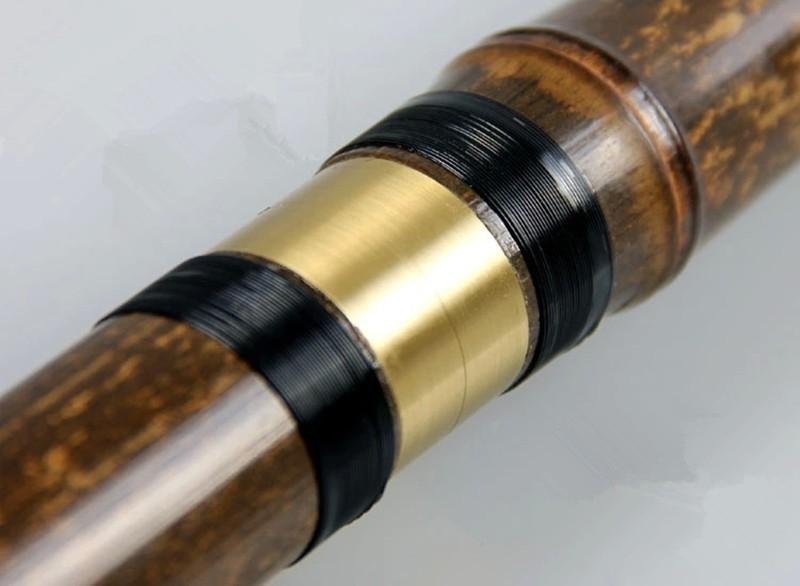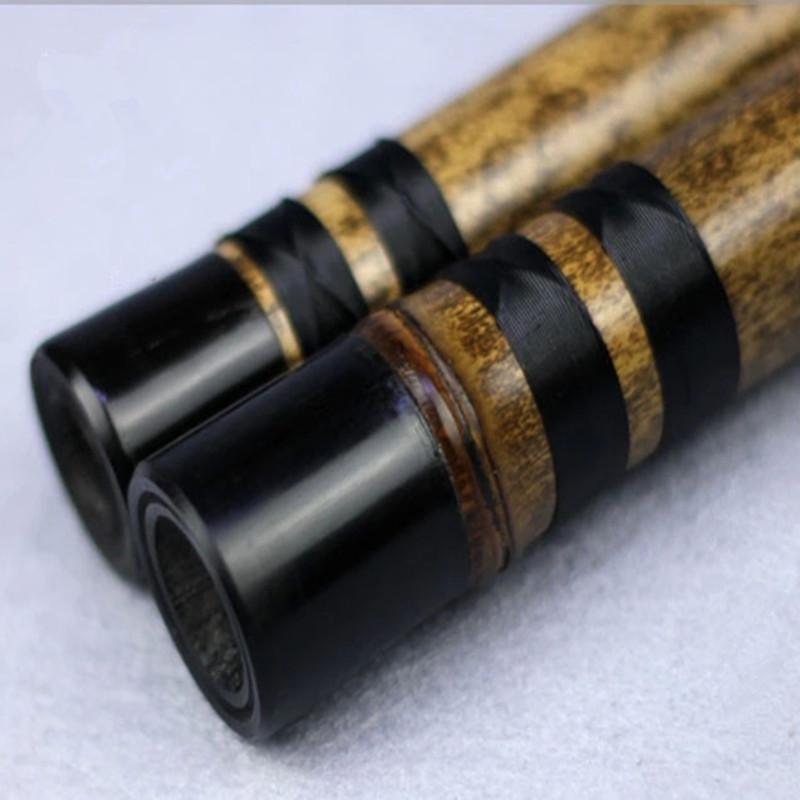The first image is the image on the left, the second image is the image on the right. For the images displayed, is the sentence "Exactly two instruments have black bands." factually correct? Answer yes or no. No. The first image is the image on the left, the second image is the image on the right. For the images displayed, is the sentence "One image shows exactly three wooden flutes, and the other image contains at least one flute displayed diagonally." factually correct? Answer yes or no. No. 